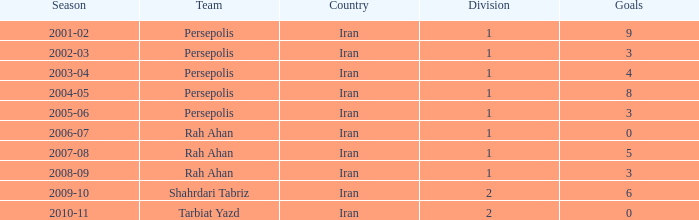What is the mean goals, when team is "rah ahan", and when division is below 1? None. 